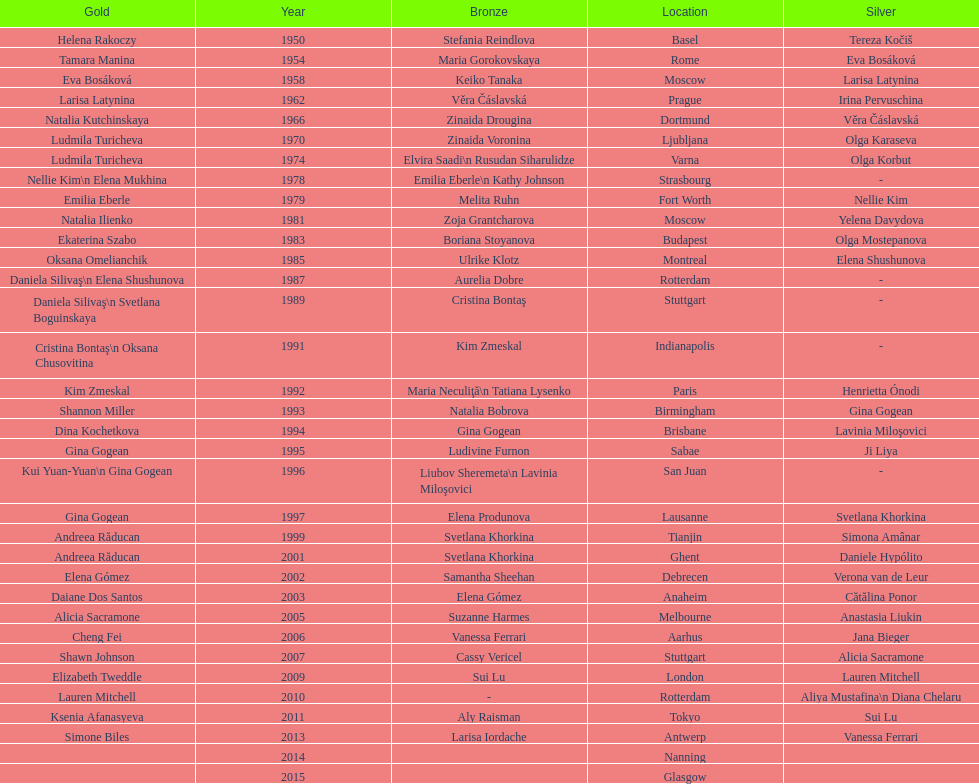Can you parse all the data within this table? {'header': ['Gold', 'Year', 'Bronze', 'Location', 'Silver'], 'rows': [['Helena Rakoczy', '1950', 'Stefania Reindlova', 'Basel', 'Tereza Kočiš'], ['Tamara Manina', '1954', 'Maria Gorokovskaya', 'Rome', 'Eva Bosáková'], ['Eva Bosáková', '1958', 'Keiko Tanaka', 'Moscow', 'Larisa Latynina'], ['Larisa Latynina', '1962', 'Věra Čáslavská', 'Prague', 'Irina Pervuschina'], ['Natalia Kutchinskaya', '1966', 'Zinaida Drougina', 'Dortmund', 'Věra Čáslavská'], ['Ludmila Turicheva', '1970', 'Zinaida Voronina', 'Ljubljana', 'Olga Karaseva'], ['Ludmila Turicheva', '1974', 'Elvira Saadi\\n Rusudan Siharulidze', 'Varna', 'Olga Korbut'], ['Nellie Kim\\n Elena Mukhina', '1978', 'Emilia Eberle\\n Kathy Johnson', 'Strasbourg', '-'], ['Emilia Eberle', '1979', 'Melita Ruhn', 'Fort Worth', 'Nellie Kim'], ['Natalia Ilienko', '1981', 'Zoja Grantcharova', 'Moscow', 'Yelena Davydova'], ['Ekaterina Szabo', '1983', 'Boriana Stoyanova', 'Budapest', 'Olga Mostepanova'], ['Oksana Omelianchik', '1985', 'Ulrike Klotz', 'Montreal', 'Elena Shushunova'], ['Daniela Silivaş\\n Elena Shushunova', '1987', 'Aurelia Dobre', 'Rotterdam', '-'], ['Daniela Silivaş\\n Svetlana Boguinskaya', '1989', 'Cristina Bontaş', 'Stuttgart', '-'], ['Cristina Bontaş\\n Oksana Chusovitina', '1991', 'Kim Zmeskal', 'Indianapolis', '-'], ['Kim Zmeskal', '1992', 'Maria Neculiţă\\n Tatiana Lysenko', 'Paris', 'Henrietta Ónodi'], ['Shannon Miller', '1993', 'Natalia Bobrova', 'Birmingham', 'Gina Gogean'], ['Dina Kochetkova', '1994', 'Gina Gogean', 'Brisbane', 'Lavinia Miloşovici'], ['Gina Gogean', '1995', 'Ludivine Furnon', 'Sabae', 'Ji Liya'], ['Kui Yuan-Yuan\\n Gina Gogean', '1996', 'Liubov Sheremeta\\n Lavinia Miloşovici', 'San Juan', '-'], ['Gina Gogean', '1997', 'Elena Produnova', 'Lausanne', 'Svetlana Khorkina'], ['Andreea Răducan', '1999', 'Svetlana Khorkina', 'Tianjin', 'Simona Amânar'], ['Andreea Răducan', '2001', 'Svetlana Khorkina', 'Ghent', 'Daniele Hypólito'], ['Elena Gómez', '2002', 'Samantha Sheehan', 'Debrecen', 'Verona van de Leur'], ['Daiane Dos Santos', '2003', 'Elena Gómez', 'Anaheim', 'Cătălina Ponor'], ['Alicia Sacramone', '2005', 'Suzanne Harmes', 'Melbourne', 'Anastasia Liukin'], ['Cheng Fei', '2006', 'Vanessa Ferrari', 'Aarhus', 'Jana Bieger'], ['Shawn Johnson', '2007', 'Cassy Vericel', 'Stuttgart', 'Alicia Sacramone'], ['Elizabeth Tweddle', '2009', 'Sui Lu', 'London', 'Lauren Mitchell'], ['Lauren Mitchell', '2010', '-', 'Rotterdam', 'Aliya Mustafina\\n Diana Chelaru'], ['Ksenia Afanasyeva', '2011', 'Aly Raisman', 'Tokyo', 'Sui Lu'], ['Simone Biles', '2013', 'Larisa Iordache', 'Antwerp', 'Vanessa Ferrari'], ['', '2014', '', 'Nanning', ''], ['', '2015', '', 'Glasgow', '']]} What is the total number of russian gymnasts that have won silver. 8. 